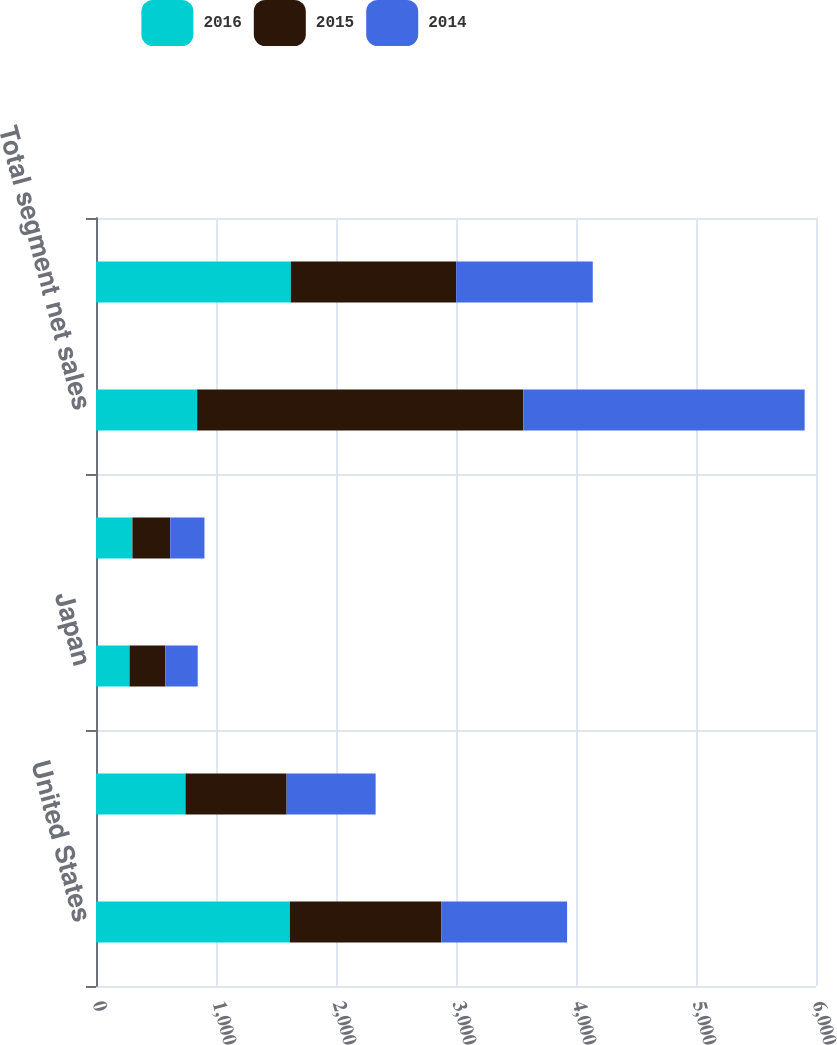Convert chart. <chart><loc_0><loc_0><loc_500><loc_500><stacked_bar_chart><ecel><fcel>United States<fcel>Europe<fcel>Japan<fcel>Rest of World<fcel>Total segment net sales<fcel>Total segment pre-tax income<nl><fcel>2016<fcel>1615.7<fcel>745.9<fcel>279.6<fcel>303.6<fcel>842.9<fcel>1623.7<nl><fcel>2015<fcel>1262.8<fcel>842.9<fcel>297.2<fcel>315.1<fcel>2718<fcel>1378.5<nl><fcel>2014<fcel>1047.3<fcel>741.4<fcel>270.8<fcel>285.1<fcel>2344.6<fcel>1137.5<nl></chart> 